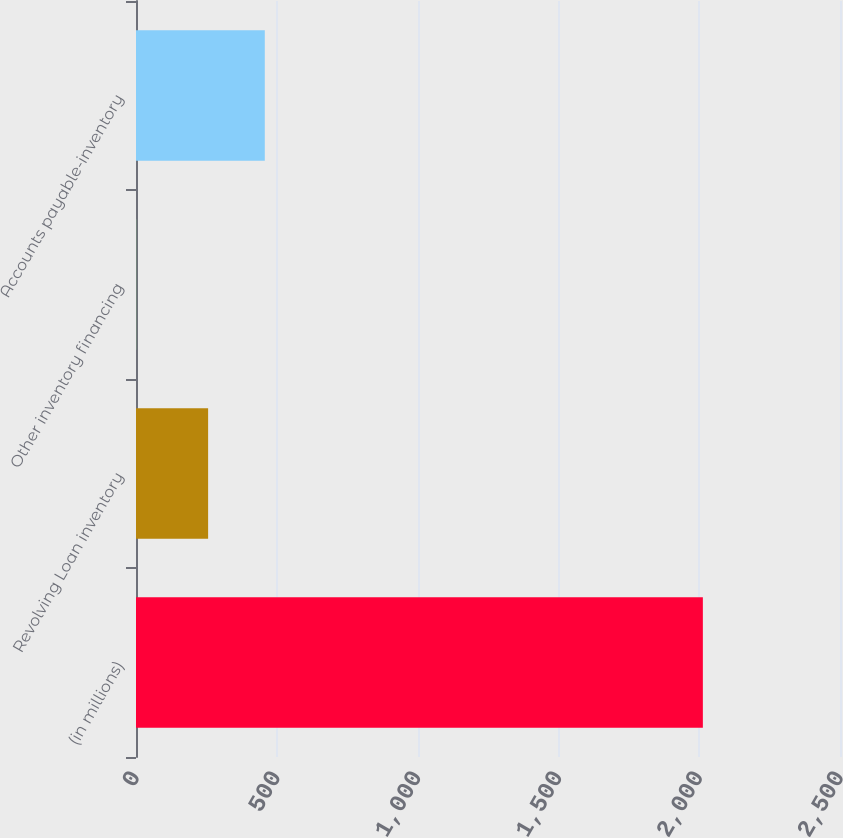Convert chart to OTSL. <chart><loc_0><loc_0><loc_500><loc_500><bar_chart><fcel>(in millions)<fcel>Revolving Loan inventory<fcel>Other inventory financing<fcel>Accounts payable-inventory<nl><fcel>2013<fcel>256.1<fcel>0.5<fcel>457.35<nl></chart> 